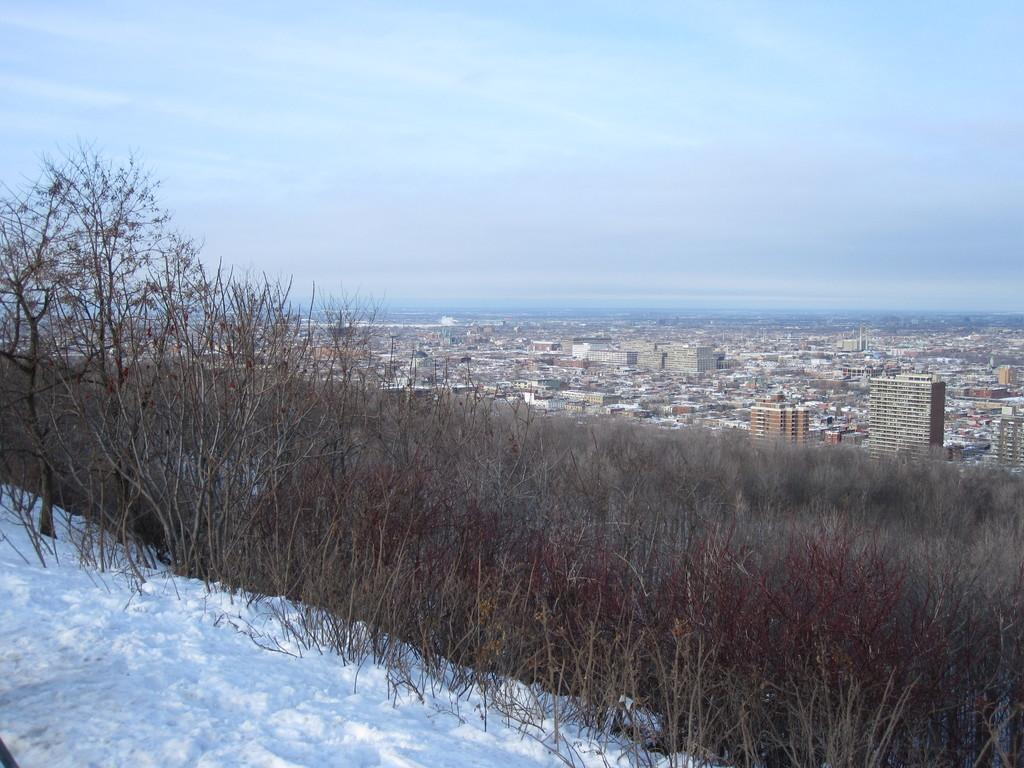What type of structures can be seen in the image? There are buildings in the image. What other natural elements are present in the image? There are trees in the image. What is the weather like in the image? There is snow visible in the image, and the sky is blue and cloudy. Can you tell me which actor is standing next to the tree in the image? There are no actors present in the image; it features buildings, trees, snow, and a blue, cloudy sky. What type of knot is tied around the tree trunk in the image? There is no knot tied around the tree trunk in the image; it is a natural element with no visible human intervention. 